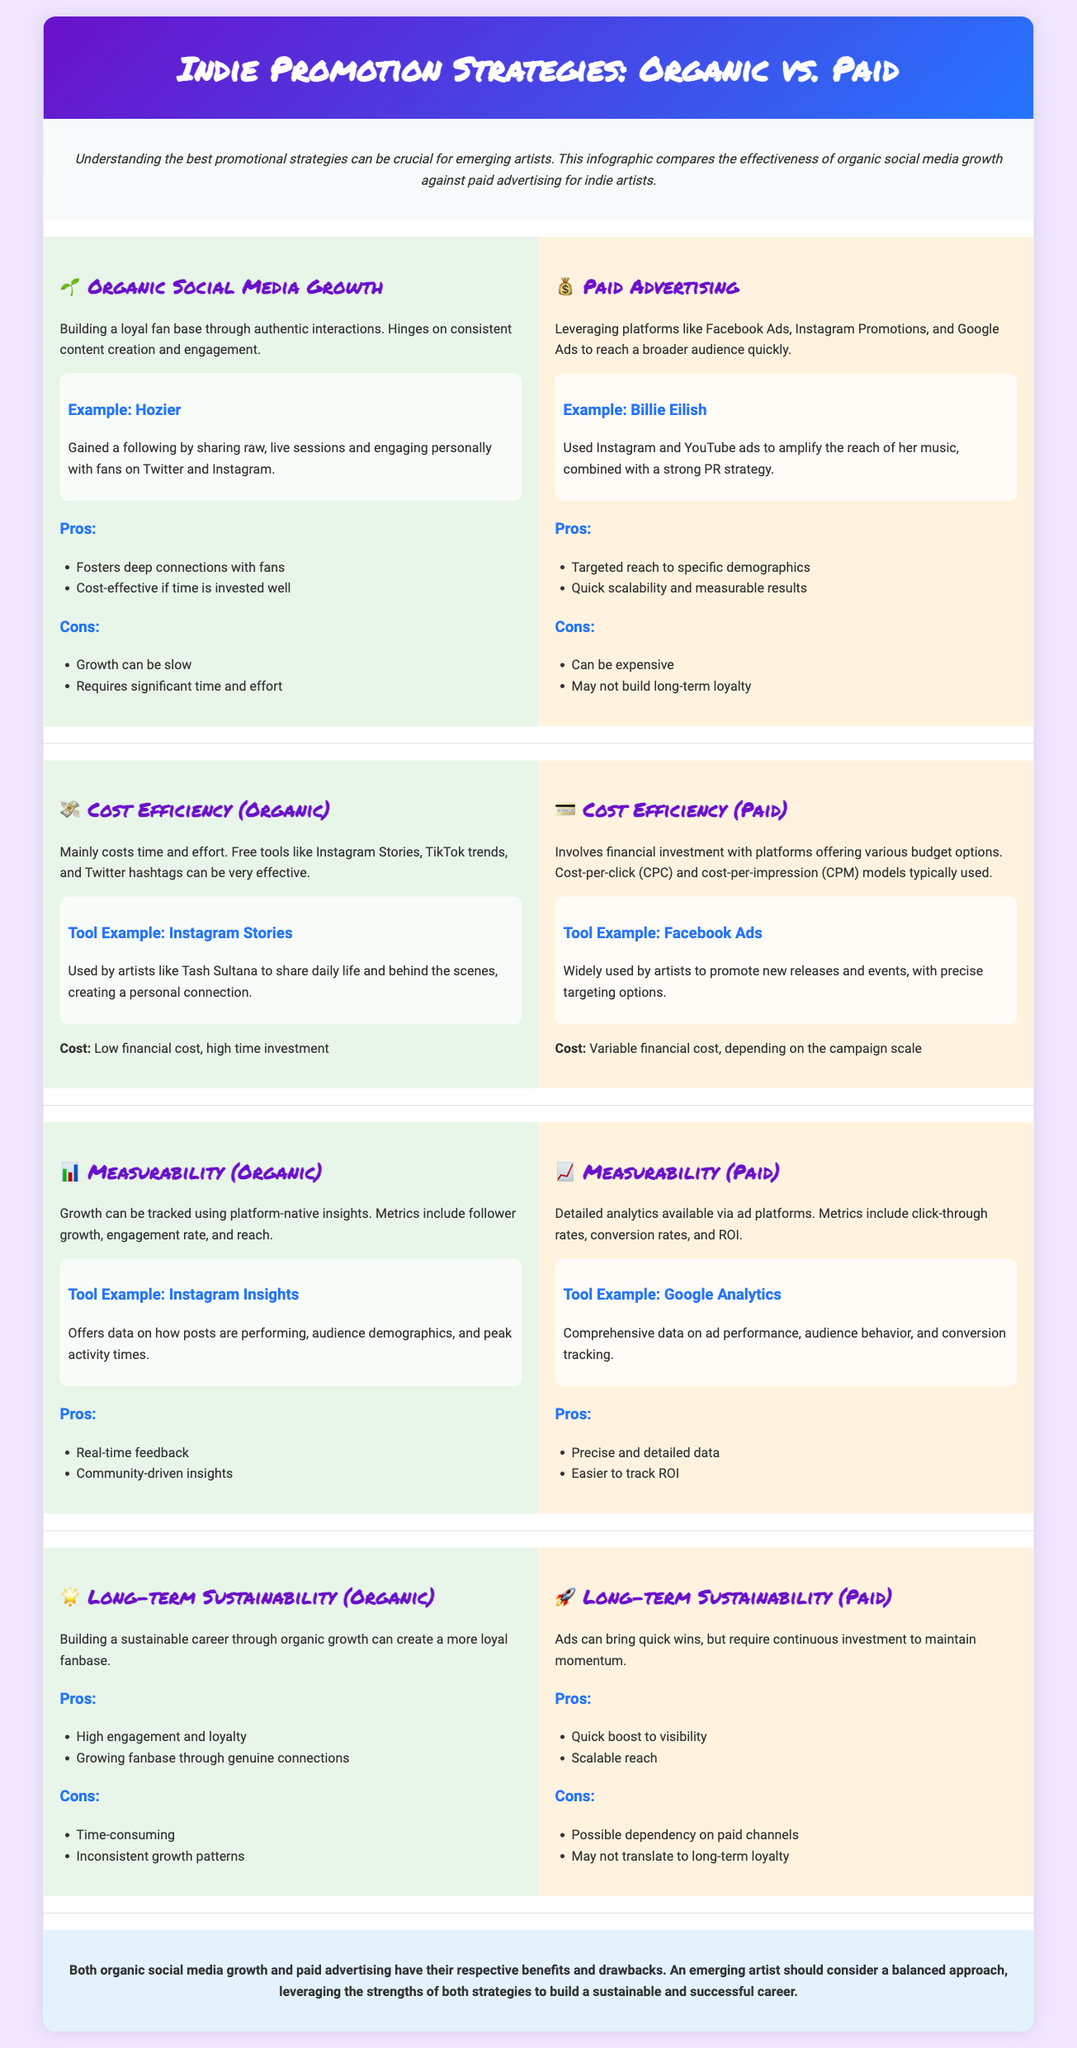What is the title of the infographic? The title of the infographic is presented in the header section of the document.
Answer: Indie Promotion Strategies: Organic vs. Paid Who is an example of an artist that used Organic Social Media Growth? The infographic provides an example of an artist mentioned in the Organic section, showcasing their strategy.
Answer: Hozier What main tool example is given for Paid Advertising? The tool example provided in the Paid Advertising section helps illustrate the effectiveness of paid strategies.
Answer: Facebook Ads Which strategy offers quick scalability and measurable results? The Paid Advertising section highlights the benefits of this strategy in reaching a broader audience quickly.
Answer: Paid Advertising What is the main cost consideration for Organic Social Media Growth? The infographic specifies that the major cost of this strategy primarily involves time and effort.
Answer: Low financial cost, high time investment What are two advantages of Organic Social Media Growth? The document lists benefits in the Organic section that highlight the positive aspects of this strategy.
Answer: Fosters deep connections with fans; Cost-effective if time is invested well Which example artist utilized Instagram and YouTube ads? This artist is cited in the Paid Advertising section as a case of leveraging ads for music promotion.
Answer: Billie Eilish What are the cons associated with long-term sustainability in Paid Advertising? The infographic discusses potential downsides of using this strategy over a longer term in the Paid section.
Answer: Possible dependency on paid channels; May not translate to long-term loyalty How is engagement measured in Organic Social Media Growth? The infographic indicates that growth can be tracked using metrics outlined in the Organic section.
Answer: Follower growth, engagement rate, and reach 